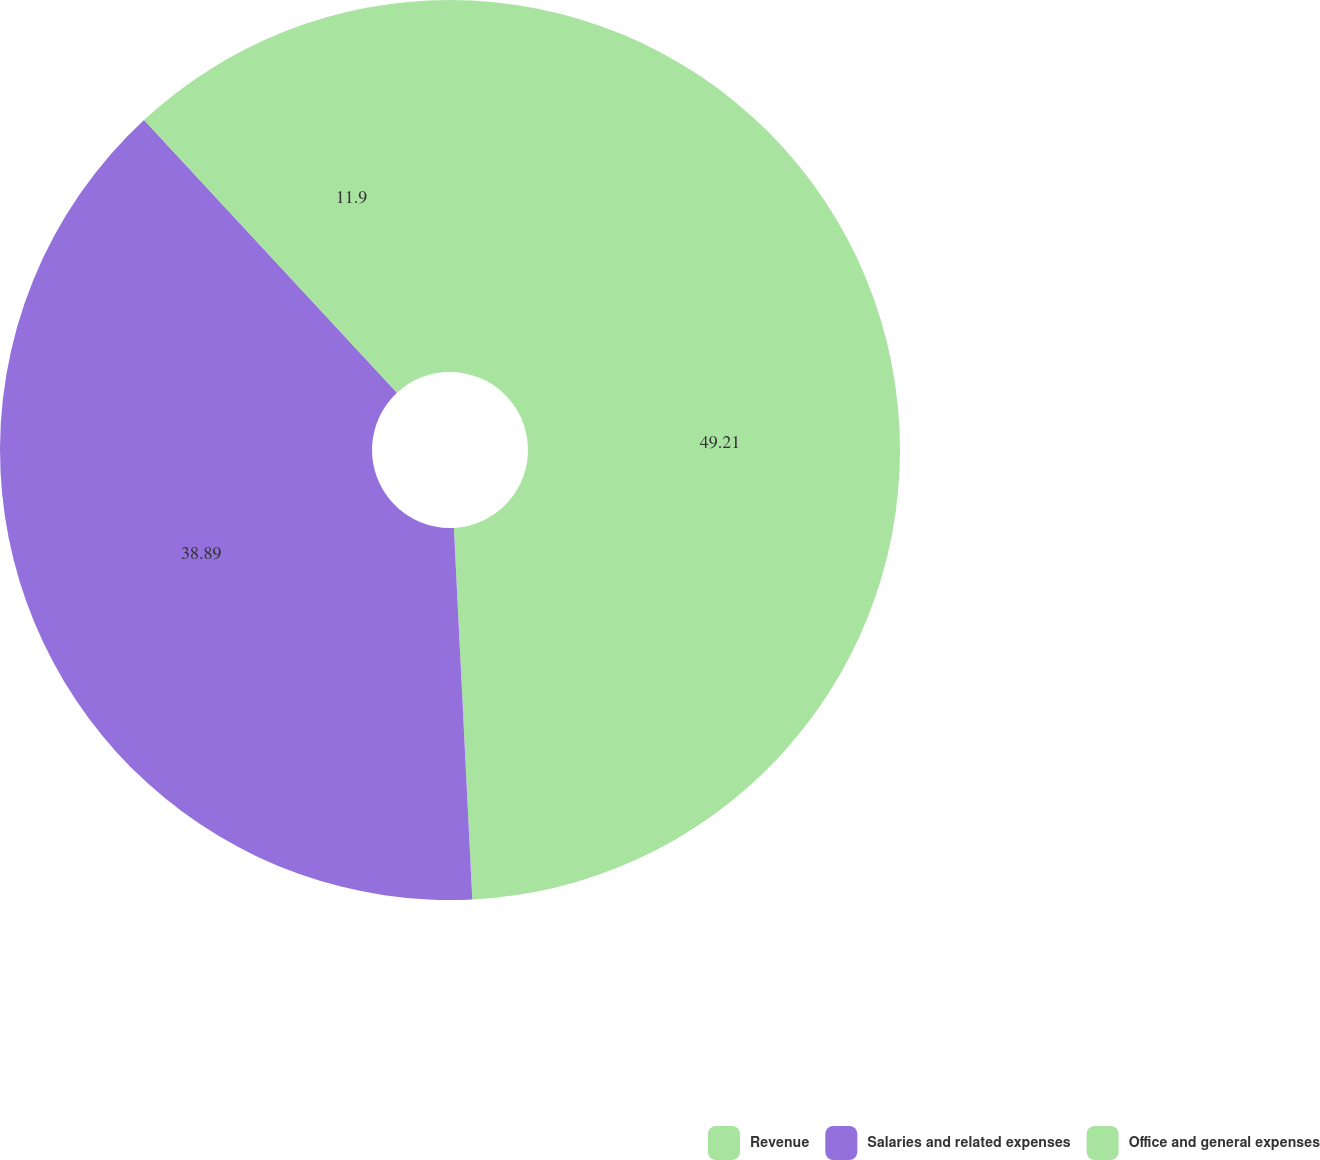Convert chart. <chart><loc_0><loc_0><loc_500><loc_500><pie_chart><fcel>Revenue<fcel>Salaries and related expenses<fcel>Office and general expenses<nl><fcel>49.21%<fcel>38.89%<fcel>11.9%<nl></chart> 